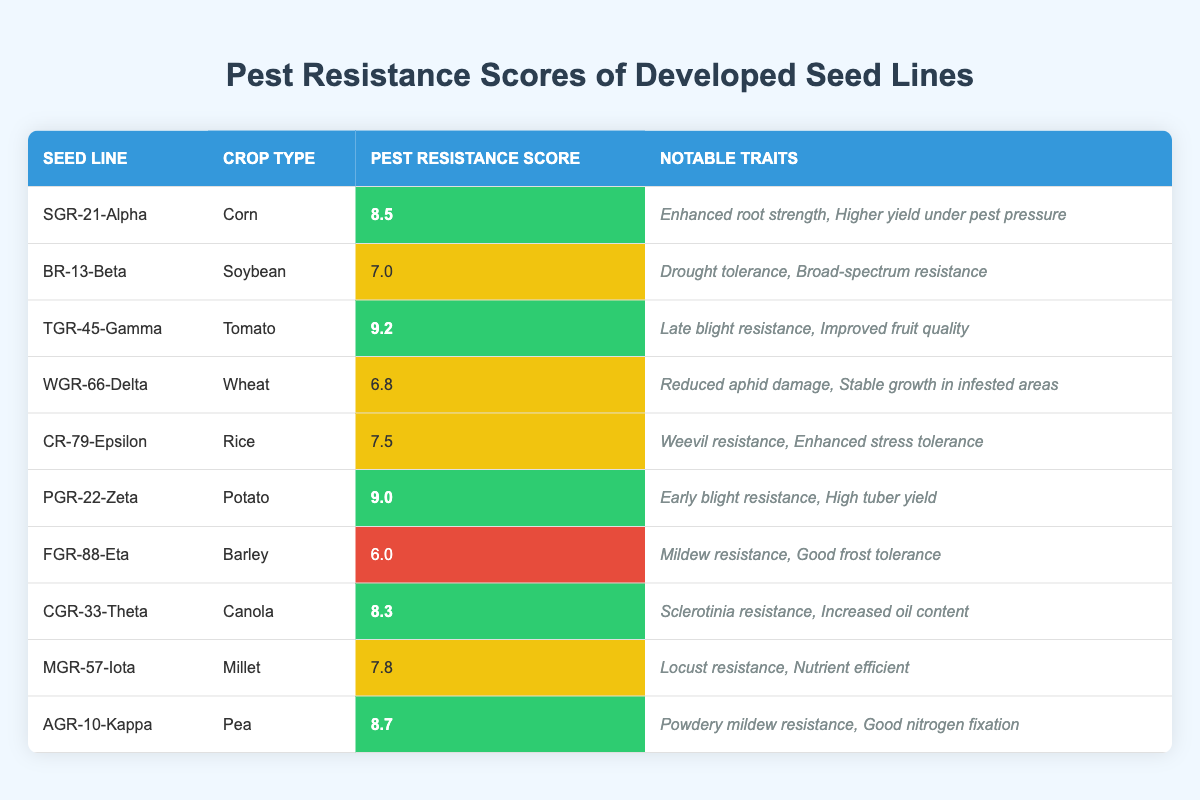What is the pest resistance score of SGR-21-Alpha? The score for SGR-21-Alpha is listed directly in the table under "Pest Resistance Score," which shows a value of 8.5.
Answer: 8.5 Which crop type has the highest pest resistance score? By examining the "Pest Resistance Score" column, TGR-45-Gamma for Tomato shows the highest score of 9.2.
Answer: Tomato How many seed lines have a pest resistance score of 8 or higher? The seed lines with scores of 8 or higher are SGR-21-Alpha (8.5), TGR-45-Gamma (9.2), PGR-22-Zeta (9.0), CGR-33-Theta (8.3), and AGR-10-Kappa (8.7), totaling 5 seed lines.
Answer: 5 What is the average pest resistance score for the seed lines? To find the average, sum all the scores (8.5 + 7.0 + 9.2 + 6.8 + 7.5 + 9.0 + 6.0 + 8.3 + 7.8 + 8.7 = 78.8) and divide by the number of seed lines (10), giving an average of 7.88.
Answer: 7.88 Does BR-13-Beta have notable traits related to pest resistance? Yes, the traits listed for BR-13-Beta include broad-spectrum resistance, confirming this seed line's traits related to pest resistance.
Answer: Yes Which crop type has the lowest pest resistance score, and what is that score? FGR-88-Eta for Barley has the lowest pest resistance score at 6.0, as seen in the table.
Answer: Barley, 6.0 Are the notable traits of SGR-21-Alpha focused on yield and strength? Yes, the traits listed are "Enhanced root strength" and "Higher yield under pest pressure," both emphasizing yield and strength.
Answer: Yes Which two seed lines have scores closest to each other, and what are their scores? Comparing the scores, WGR-66-Delta (6.8) and CR-79-Epsilon (7.5) have the closest scores, with a difference of 0.7.
Answer: WGR-66-Delta (6.8) and CR-79-Epsilon (7.5) How many seed lines have a score below 7? Only one seed line, FGR-88-Eta, has a score below 7, which is 6.0.
Answer: 1 What notable trait is common among seed lines with high pest resistance scores? The notable traits often include specific resistances (like "Late blight resistance" for TGR-45-Gamma) indicating strength against various pests, which is common among the high-scoring lines.
Answer: Specific resistances 